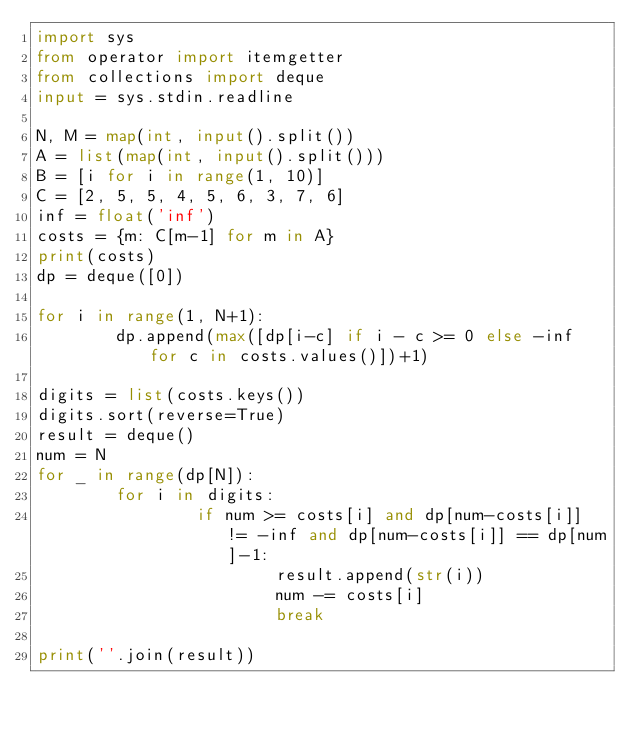<code> <loc_0><loc_0><loc_500><loc_500><_Python_>import sys
from operator import itemgetter
from collections import deque
input = sys.stdin.readline

N, M = map(int, input().split())
A = list(map(int, input().split()))
B = [i for i in range(1, 10)]
C = [2, 5, 5, 4, 5, 6, 3, 7, 6]
inf = float('inf')
costs = {m: C[m-1] for m in A}
print(costs)
dp = deque([0])

for i in range(1, N+1):
        dp.append(max([dp[i-c] if i - c >= 0 else -inf for c in costs.values()])+1)

digits = list(costs.keys())
digits.sort(reverse=True)
result = deque()
num = N
for _ in range(dp[N]):
        for i in digits:
                if num >= costs[i] and dp[num-costs[i]] != -inf and dp[num-costs[i]] == dp[num]-1:
                        result.append(str(i))
                        num -= costs[i]
                        break

print(''.join(result))</code> 